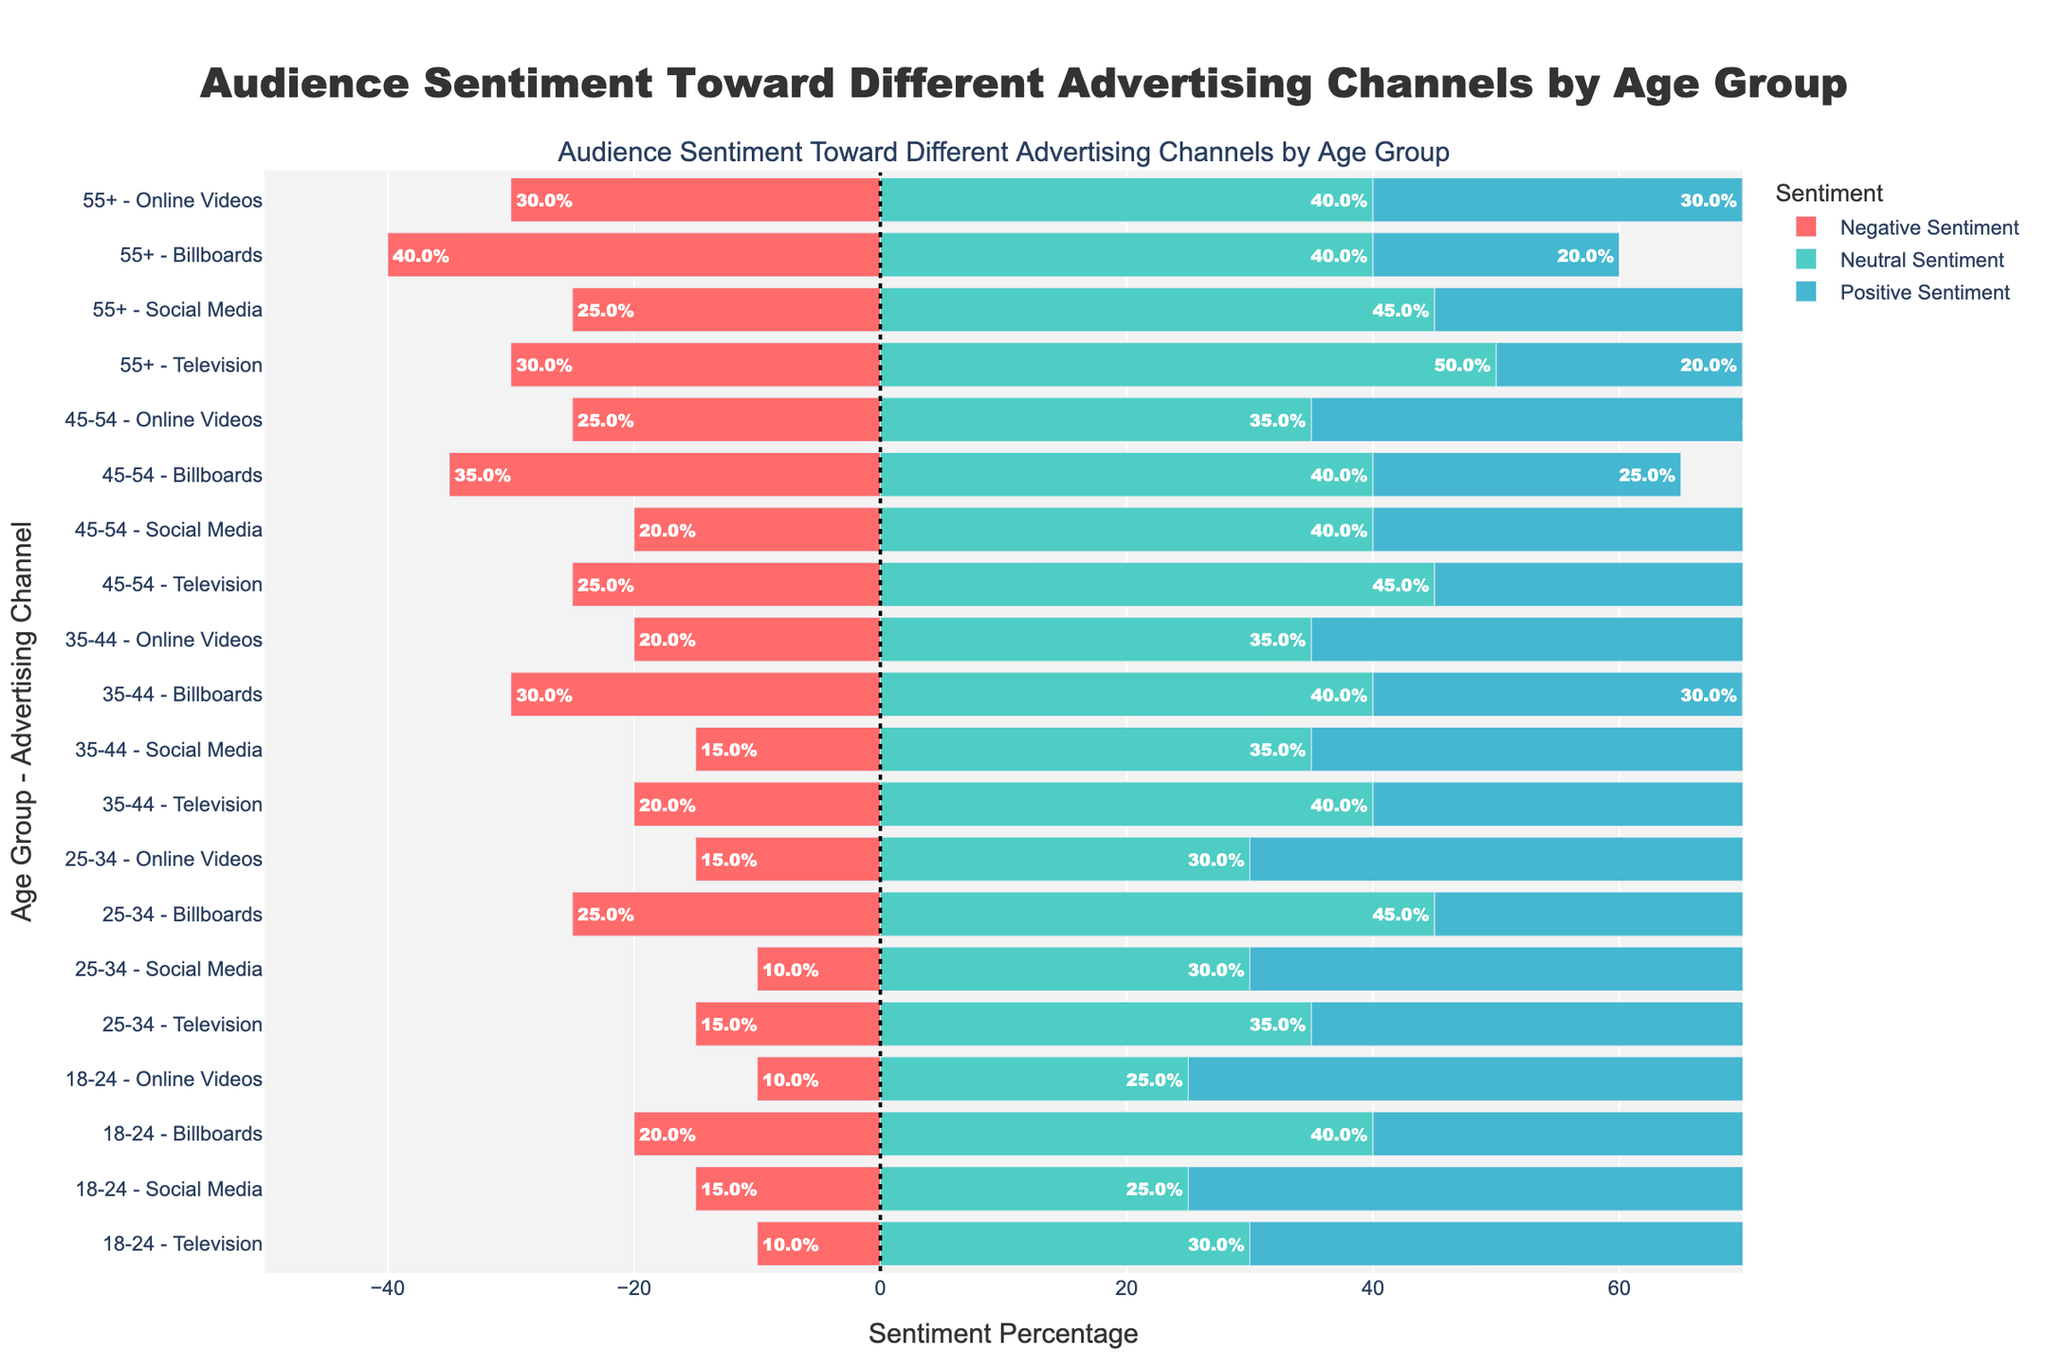Which age group has the highest positive sentiment for Social Media? Look for the bars corresponding to Social Media in each age group. The longest positive sentiment bar for Social Media is in the 18-24 age group.
Answer: 18-24 Between the 25-34 and 35-44 age groups, which has a higher negative sentiment towards Billboards? Compare the lengths of the negative sentiment bars for Billboards between these two age groups. The 35-44 age group has a negative sentiment of 30% compared to 25% in the 25-34 age group.
Answer: 35-44 What is the average positive sentiment for Online Videos across all age groups? Sum the positive sentiments for Online Videos: 65% (18-24) + 55% (25-34) + 45% (35-44) + 40% (45-54) + 30% (55+), then divide by the number of age groups (5). Calculation: (65 + 55 + 45 + 40 + 30) / 5 = 47%.
Answer: 47% Which advertising channel generally has the highest negative sentiment across all age groups? By visually checking each age group's bars, Billboards frequently show longer negative sentiment bars compared to other channels. Billboards often have higher negative sentiment values consistently.
Answer: Billboards For the 55+ age group, which advertising channel has the highest combined neutral and positive sentiment? By checking the 55+ group, add the neutral and positive sentiments for each channel: Television (50% + 20% = 70%), Social Media (45% + 30% = 75%), Billboards (40% + 20% = 60%), Online Videos (40% + 30% = 70%). Social Media has the highest combined sentiment.
Answer: Social Media In the 35-44 age group, how does the negative sentiment towards social media compare to television? Compare the lengths of the negative sentiment bars in the 35-44 age group for social media and television. Social Media has a negative sentiment of 15%, whereas Television has 20%, so Television has a higher negative sentiment.
Answer: Television What percentage of people aged 18-24 have a neutral sentiment towards Billboards? Locate the bar for Billboards in the 18-24 age group and read the value of the neutral sentiment, which is 40%.
Answer: 40% What is the total neutral sentiment percentage for all advertising channels in the 45-54 age group? Add the neutral sentiment percentages for all channels in the 45-54 group: Television (45%) + Social Media (40%) + Billboards (40%) + Online Videos (35%). Calculation: 45 + 40 + 40 + 35 = 160%.
Answer: 160% 